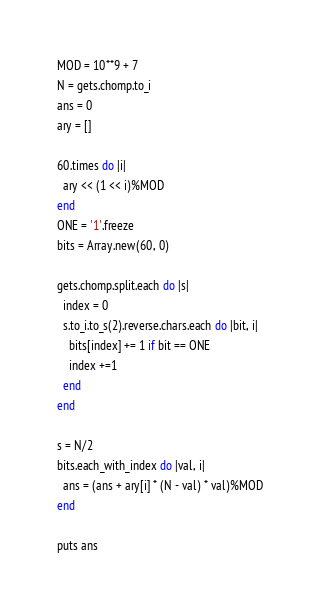Convert code to text. <code><loc_0><loc_0><loc_500><loc_500><_Ruby_>MOD = 10**9 + 7
N = gets.chomp.to_i
ans = 0
ary = []

60.times do |i|
  ary << (1 << i)%MOD
end
ONE = '1'.freeze
bits = Array.new(60, 0)

gets.chomp.split.each do |s|
  index = 0
  s.to_i.to_s(2).reverse.chars.each do |bit, i|
    bits[index] += 1 if bit == ONE
    index +=1
  end
end

s = N/2
bits.each_with_index do |val, i|
  ans = (ans + ary[i] * (N - val) * val)%MOD
end

puts ans
</code> 